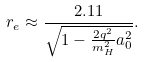<formula> <loc_0><loc_0><loc_500><loc_500>r _ { e } \approx \frac { 2 . 1 1 } { \sqrt { 1 - \frac { 2 q ^ { 2 } } { m _ { H } ^ { 2 } } a _ { 0 } ^ { 2 } } } .</formula> 